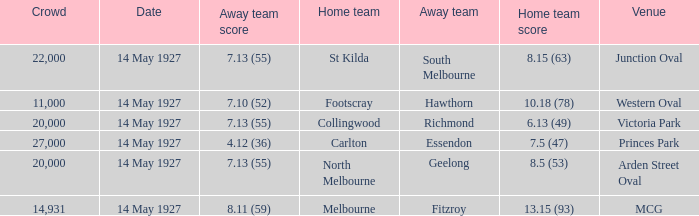How much is the sum of every crowd in attendance when the away score was 7.13 (55) for Richmond? 20000.0. 